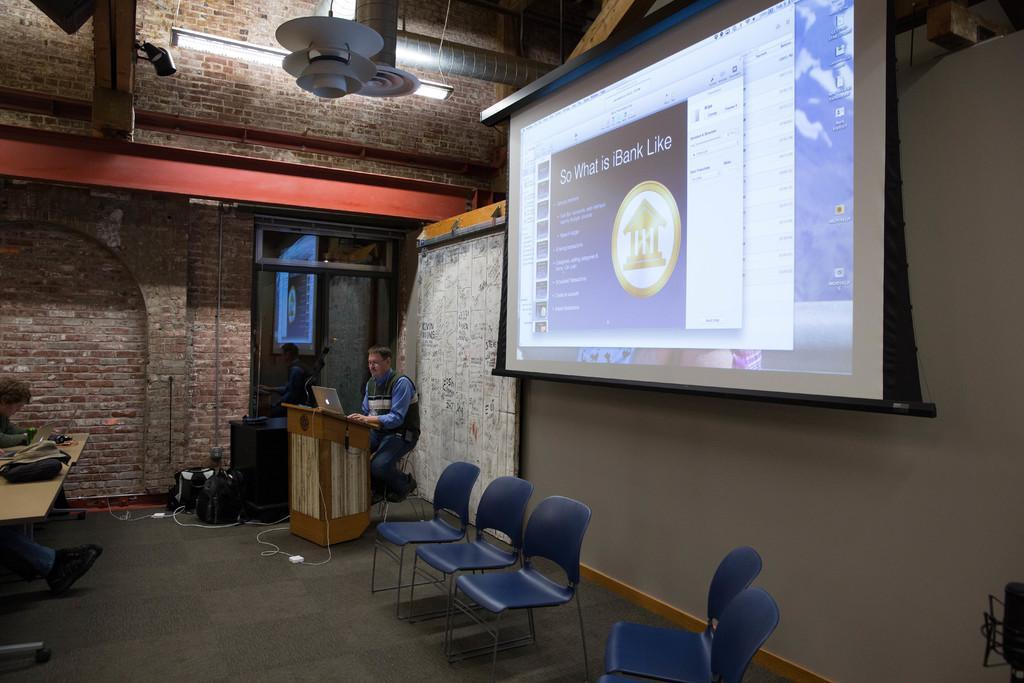Please provide a concise description of this image. In this picture there is a man sitting in front of podium on which a laptop was placed. There are some chairs here. There is a projector display screen. In the background there is a wall and a light here. 